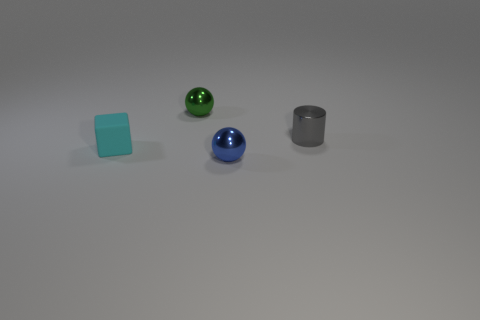Add 4 large cyan metal cubes. How many objects exist? 8 Subtract all green balls. Subtract all brown cylinders. How many balls are left? 1 Subtract all small cyan cubes. Subtract all yellow metallic cubes. How many objects are left? 3 Add 1 blue spheres. How many blue spheres are left? 2 Add 1 small green spheres. How many small green spheres exist? 2 Subtract 0 red cylinders. How many objects are left? 4 